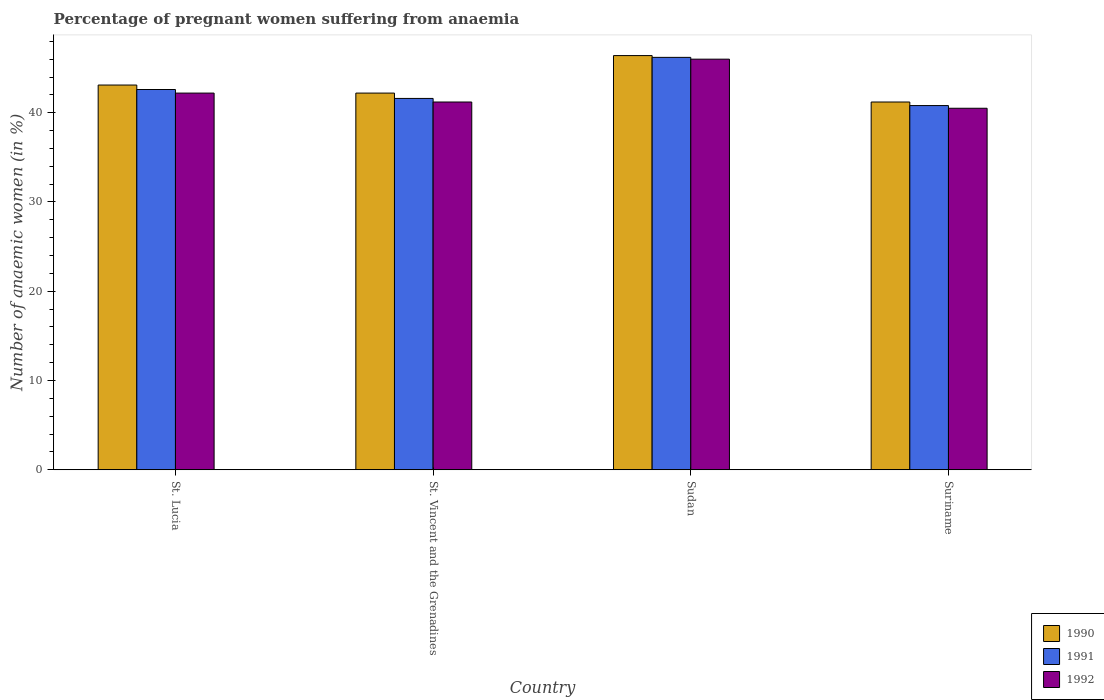How many different coloured bars are there?
Provide a succinct answer. 3. How many bars are there on the 4th tick from the left?
Give a very brief answer. 3. What is the label of the 1st group of bars from the left?
Keep it short and to the point. St. Lucia. What is the number of anaemic women in 1991 in St. Vincent and the Grenadines?
Provide a succinct answer. 41.6. Across all countries, what is the maximum number of anaemic women in 1991?
Your answer should be compact. 46.2. Across all countries, what is the minimum number of anaemic women in 1990?
Offer a very short reply. 41.2. In which country was the number of anaemic women in 1991 maximum?
Make the answer very short. Sudan. In which country was the number of anaemic women in 1990 minimum?
Make the answer very short. Suriname. What is the total number of anaemic women in 1990 in the graph?
Keep it short and to the point. 172.9. What is the difference between the number of anaemic women in 1992 in Sudan and that in Suriname?
Your answer should be compact. 5.5. What is the difference between the number of anaemic women in 1990 in Sudan and the number of anaemic women in 1992 in St. Lucia?
Offer a terse response. 4.2. What is the average number of anaemic women in 1991 per country?
Make the answer very short. 42.8. What is the difference between the number of anaemic women of/in 1990 and number of anaemic women of/in 1992 in Suriname?
Your response must be concise. 0.7. What is the ratio of the number of anaemic women in 1990 in St. Lucia to that in Sudan?
Provide a succinct answer. 0.93. Is the difference between the number of anaemic women in 1990 in Sudan and Suriname greater than the difference between the number of anaemic women in 1992 in Sudan and Suriname?
Ensure brevity in your answer.  No. What is the difference between the highest and the lowest number of anaemic women in 1991?
Ensure brevity in your answer.  5.4. In how many countries, is the number of anaemic women in 1991 greater than the average number of anaemic women in 1991 taken over all countries?
Your answer should be very brief. 1. Is the sum of the number of anaemic women in 1991 in St. Lucia and Sudan greater than the maximum number of anaemic women in 1992 across all countries?
Offer a very short reply. Yes. What does the 1st bar from the right in St. Vincent and the Grenadines represents?
Ensure brevity in your answer.  1992. Is it the case that in every country, the sum of the number of anaemic women in 1992 and number of anaemic women in 1990 is greater than the number of anaemic women in 1991?
Give a very brief answer. Yes. How many bars are there?
Keep it short and to the point. 12. Are all the bars in the graph horizontal?
Make the answer very short. No. Are the values on the major ticks of Y-axis written in scientific E-notation?
Provide a short and direct response. No. Does the graph contain any zero values?
Make the answer very short. No. Does the graph contain grids?
Offer a terse response. No. Where does the legend appear in the graph?
Keep it short and to the point. Bottom right. How many legend labels are there?
Ensure brevity in your answer.  3. What is the title of the graph?
Provide a succinct answer. Percentage of pregnant women suffering from anaemia. What is the label or title of the X-axis?
Your answer should be compact. Country. What is the label or title of the Y-axis?
Offer a terse response. Number of anaemic women (in %). What is the Number of anaemic women (in %) in 1990 in St. Lucia?
Ensure brevity in your answer.  43.1. What is the Number of anaemic women (in %) in 1991 in St. Lucia?
Make the answer very short. 42.6. What is the Number of anaemic women (in %) in 1992 in St. Lucia?
Provide a short and direct response. 42.2. What is the Number of anaemic women (in %) of 1990 in St. Vincent and the Grenadines?
Your answer should be compact. 42.2. What is the Number of anaemic women (in %) of 1991 in St. Vincent and the Grenadines?
Make the answer very short. 41.6. What is the Number of anaemic women (in %) of 1992 in St. Vincent and the Grenadines?
Your answer should be very brief. 41.2. What is the Number of anaemic women (in %) of 1990 in Sudan?
Ensure brevity in your answer.  46.4. What is the Number of anaemic women (in %) of 1991 in Sudan?
Offer a terse response. 46.2. What is the Number of anaemic women (in %) in 1990 in Suriname?
Make the answer very short. 41.2. What is the Number of anaemic women (in %) of 1991 in Suriname?
Offer a terse response. 40.8. What is the Number of anaemic women (in %) in 1992 in Suriname?
Offer a very short reply. 40.5. Across all countries, what is the maximum Number of anaemic women (in %) in 1990?
Keep it short and to the point. 46.4. Across all countries, what is the maximum Number of anaemic women (in %) of 1991?
Provide a short and direct response. 46.2. Across all countries, what is the minimum Number of anaemic women (in %) in 1990?
Your answer should be compact. 41.2. Across all countries, what is the minimum Number of anaemic women (in %) in 1991?
Provide a short and direct response. 40.8. Across all countries, what is the minimum Number of anaemic women (in %) in 1992?
Provide a short and direct response. 40.5. What is the total Number of anaemic women (in %) of 1990 in the graph?
Your answer should be very brief. 172.9. What is the total Number of anaemic women (in %) in 1991 in the graph?
Your answer should be compact. 171.2. What is the total Number of anaemic women (in %) in 1992 in the graph?
Give a very brief answer. 169.9. What is the difference between the Number of anaemic women (in %) of 1990 in St. Lucia and that in St. Vincent and the Grenadines?
Offer a terse response. 0.9. What is the difference between the Number of anaemic women (in %) in 1991 in St. Lucia and that in St. Vincent and the Grenadines?
Give a very brief answer. 1. What is the difference between the Number of anaemic women (in %) in 1992 in St. Lucia and that in St. Vincent and the Grenadines?
Offer a terse response. 1. What is the difference between the Number of anaemic women (in %) of 1990 in St. Lucia and that in Sudan?
Make the answer very short. -3.3. What is the difference between the Number of anaemic women (in %) in 1992 in St. Lucia and that in Sudan?
Give a very brief answer. -3.8. What is the difference between the Number of anaemic women (in %) in 1991 in St. Lucia and that in Suriname?
Offer a terse response. 1.8. What is the difference between the Number of anaemic women (in %) of 1992 in St. Lucia and that in Suriname?
Ensure brevity in your answer.  1.7. What is the difference between the Number of anaemic women (in %) in 1991 in St. Vincent and the Grenadines and that in Sudan?
Ensure brevity in your answer.  -4.6. What is the difference between the Number of anaemic women (in %) in 1992 in St. Vincent and the Grenadines and that in Suriname?
Ensure brevity in your answer.  0.7. What is the difference between the Number of anaemic women (in %) in 1990 in Sudan and that in Suriname?
Provide a short and direct response. 5.2. What is the difference between the Number of anaemic women (in %) of 1992 in Sudan and that in Suriname?
Your answer should be compact. 5.5. What is the difference between the Number of anaemic women (in %) of 1990 in St. Lucia and the Number of anaemic women (in %) of 1991 in St. Vincent and the Grenadines?
Provide a succinct answer. 1.5. What is the difference between the Number of anaemic women (in %) of 1990 in St. Lucia and the Number of anaemic women (in %) of 1992 in Sudan?
Make the answer very short. -2.9. What is the difference between the Number of anaemic women (in %) in 1991 in St. Lucia and the Number of anaemic women (in %) in 1992 in Sudan?
Your answer should be compact. -3.4. What is the difference between the Number of anaemic women (in %) in 1990 in St. Lucia and the Number of anaemic women (in %) in 1992 in Suriname?
Your response must be concise. 2.6. What is the difference between the Number of anaemic women (in %) in 1991 in St. Lucia and the Number of anaemic women (in %) in 1992 in Suriname?
Keep it short and to the point. 2.1. What is the difference between the Number of anaemic women (in %) of 1990 in St. Vincent and the Grenadines and the Number of anaemic women (in %) of 1992 in Sudan?
Provide a short and direct response. -3.8. What is the difference between the Number of anaemic women (in %) in 1991 in St. Vincent and the Grenadines and the Number of anaemic women (in %) in 1992 in Sudan?
Your answer should be compact. -4.4. What is the difference between the Number of anaemic women (in %) of 1990 in Sudan and the Number of anaemic women (in %) of 1991 in Suriname?
Offer a very short reply. 5.6. What is the difference between the Number of anaemic women (in %) in 1991 in Sudan and the Number of anaemic women (in %) in 1992 in Suriname?
Ensure brevity in your answer.  5.7. What is the average Number of anaemic women (in %) of 1990 per country?
Your answer should be compact. 43.23. What is the average Number of anaemic women (in %) of 1991 per country?
Make the answer very short. 42.8. What is the average Number of anaemic women (in %) of 1992 per country?
Your response must be concise. 42.48. What is the difference between the Number of anaemic women (in %) of 1990 and Number of anaemic women (in %) of 1991 in St. Lucia?
Your answer should be very brief. 0.5. What is the difference between the Number of anaemic women (in %) of 1990 and Number of anaemic women (in %) of 1992 in St. Lucia?
Offer a very short reply. 0.9. What is the difference between the Number of anaemic women (in %) of 1991 and Number of anaemic women (in %) of 1992 in St. Lucia?
Keep it short and to the point. 0.4. What is the difference between the Number of anaemic women (in %) in 1990 and Number of anaemic women (in %) in 1991 in St. Vincent and the Grenadines?
Give a very brief answer. 0.6. What is the difference between the Number of anaemic women (in %) in 1991 and Number of anaemic women (in %) in 1992 in St. Vincent and the Grenadines?
Offer a very short reply. 0.4. What is the difference between the Number of anaemic women (in %) of 1991 and Number of anaemic women (in %) of 1992 in Sudan?
Offer a terse response. 0.2. What is the difference between the Number of anaemic women (in %) in 1990 and Number of anaemic women (in %) in 1991 in Suriname?
Offer a terse response. 0.4. What is the difference between the Number of anaemic women (in %) of 1990 and Number of anaemic women (in %) of 1992 in Suriname?
Your answer should be very brief. 0.7. What is the ratio of the Number of anaemic women (in %) in 1990 in St. Lucia to that in St. Vincent and the Grenadines?
Make the answer very short. 1.02. What is the ratio of the Number of anaemic women (in %) in 1991 in St. Lucia to that in St. Vincent and the Grenadines?
Ensure brevity in your answer.  1.02. What is the ratio of the Number of anaemic women (in %) of 1992 in St. Lucia to that in St. Vincent and the Grenadines?
Provide a succinct answer. 1.02. What is the ratio of the Number of anaemic women (in %) of 1990 in St. Lucia to that in Sudan?
Give a very brief answer. 0.93. What is the ratio of the Number of anaemic women (in %) in 1991 in St. Lucia to that in Sudan?
Offer a very short reply. 0.92. What is the ratio of the Number of anaemic women (in %) in 1992 in St. Lucia to that in Sudan?
Offer a terse response. 0.92. What is the ratio of the Number of anaemic women (in %) in 1990 in St. Lucia to that in Suriname?
Your response must be concise. 1.05. What is the ratio of the Number of anaemic women (in %) in 1991 in St. Lucia to that in Suriname?
Make the answer very short. 1.04. What is the ratio of the Number of anaemic women (in %) of 1992 in St. Lucia to that in Suriname?
Give a very brief answer. 1.04. What is the ratio of the Number of anaemic women (in %) of 1990 in St. Vincent and the Grenadines to that in Sudan?
Provide a short and direct response. 0.91. What is the ratio of the Number of anaemic women (in %) in 1991 in St. Vincent and the Grenadines to that in Sudan?
Give a very brief answer. 0.9. What is the ratio of the Number of anaemic women (in %) in 1992 in St. Vincent and the Grenadines to that in Sudan?
Make the answer very short. 0.9. What is the ratio of the Number of anaemic women (in %) of 1990 in St. Vincent and the Grenadines to that in Suriname?
Offer a terse response. 1.02. What is the ratio of the Number of anaemic women (in %) of 1991 in St. Vincent and the Grenadines to that in Suriname?
Provide a short and direct response. 1.02. What is the ratio of the Number of anaemic women (in %) in 1992 in St. Vincent and the Grenadines to that in Suriname?
Your response must be concise. 1.02. What is the ratio of the Number of anaemic women (in %) of 1990 in Sudan to that in Suriname?
Your answer should be very brief. 1.13. What is the ratio of the Number of anaemic women (in %) of 1991 in Sudan to that in Suriname?
Your response must be concise. 1.13. What is the ratio of the Number of anaemic women (in %) in 1992 in Sudan to that in Suriname?
Keep it short and to the point. 1.14. What is the difference between the highest and the second highest Number of anaemic women (in %) in 1990?
Offer a terse response. 3.3. What is the difference between the highest and the lowest Number of anaemic women (in %) in 1992?
Your answer should be compact. 5.5. 